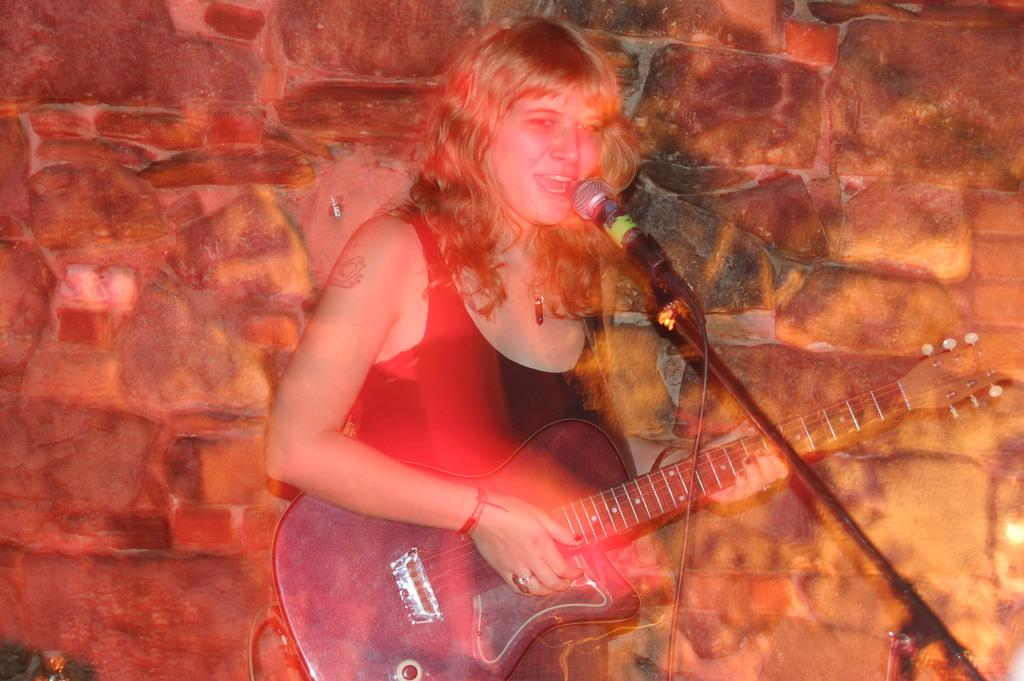Who is the main subject in the image? There is a woman in the image. What is the woman doing in the image? The woman is playing a guitar and singing. What is the woman standing in front of? The woman is in front of a microphone. What can be seen in the background of the image? There is a wall in the background of the image. What type of vessel is the woman using to drink water in the image? There is no vessel or water present in the image; the woman is playing a guitar and singing. 